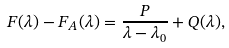Convert formula to latex. <formula><loc_0><loc_0><loc_500><loc_500>F ( \lambda ) - F _ { A } ( \lambda ) = \frac { P } { \lambda - \lambda _ { 0 } } + Q ( \lambda ) ,</formula> 